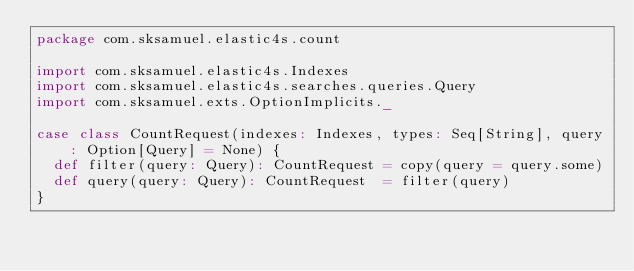Convert code to text. <code><loc_0><loc_0><loc_500><loc_500><_Scala_>package com.sksamuel.elastic4s.count

import com.sksamuel.elastic4s.Indexes
import com.sksamuel.elastic4s.searches.queries.Query
import com.sksamuel.exts.OptionImplicits._

case class CountRequest(indexes: Indexes, types: Seq[String], query: Option[Query] = None) {
  def filter(query: Query): CountRequest = copy(query = query.some)
  def query(query: Query): CountRequest  = filter(query)
}
</code> 